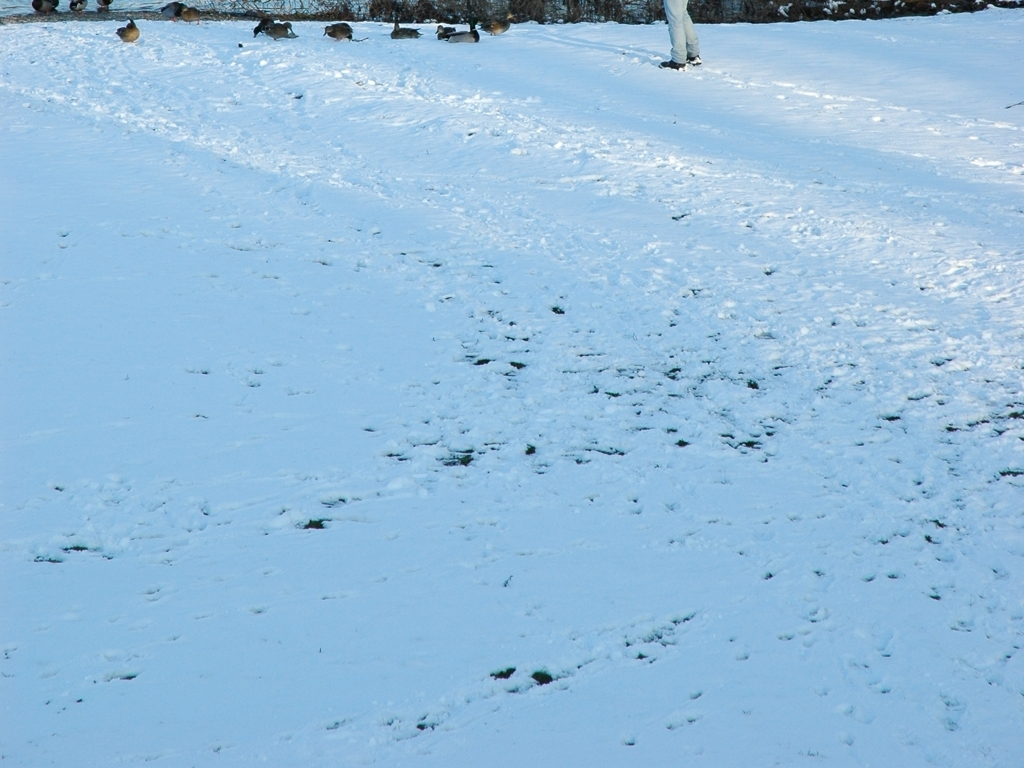What time of day does this photo appear to have been taken based on the lighting and shadows? The long shadows and the quality of light in this photo suggest it might have been taken either early in the morning or late in the afternoon when the sun is lower in the sky. 